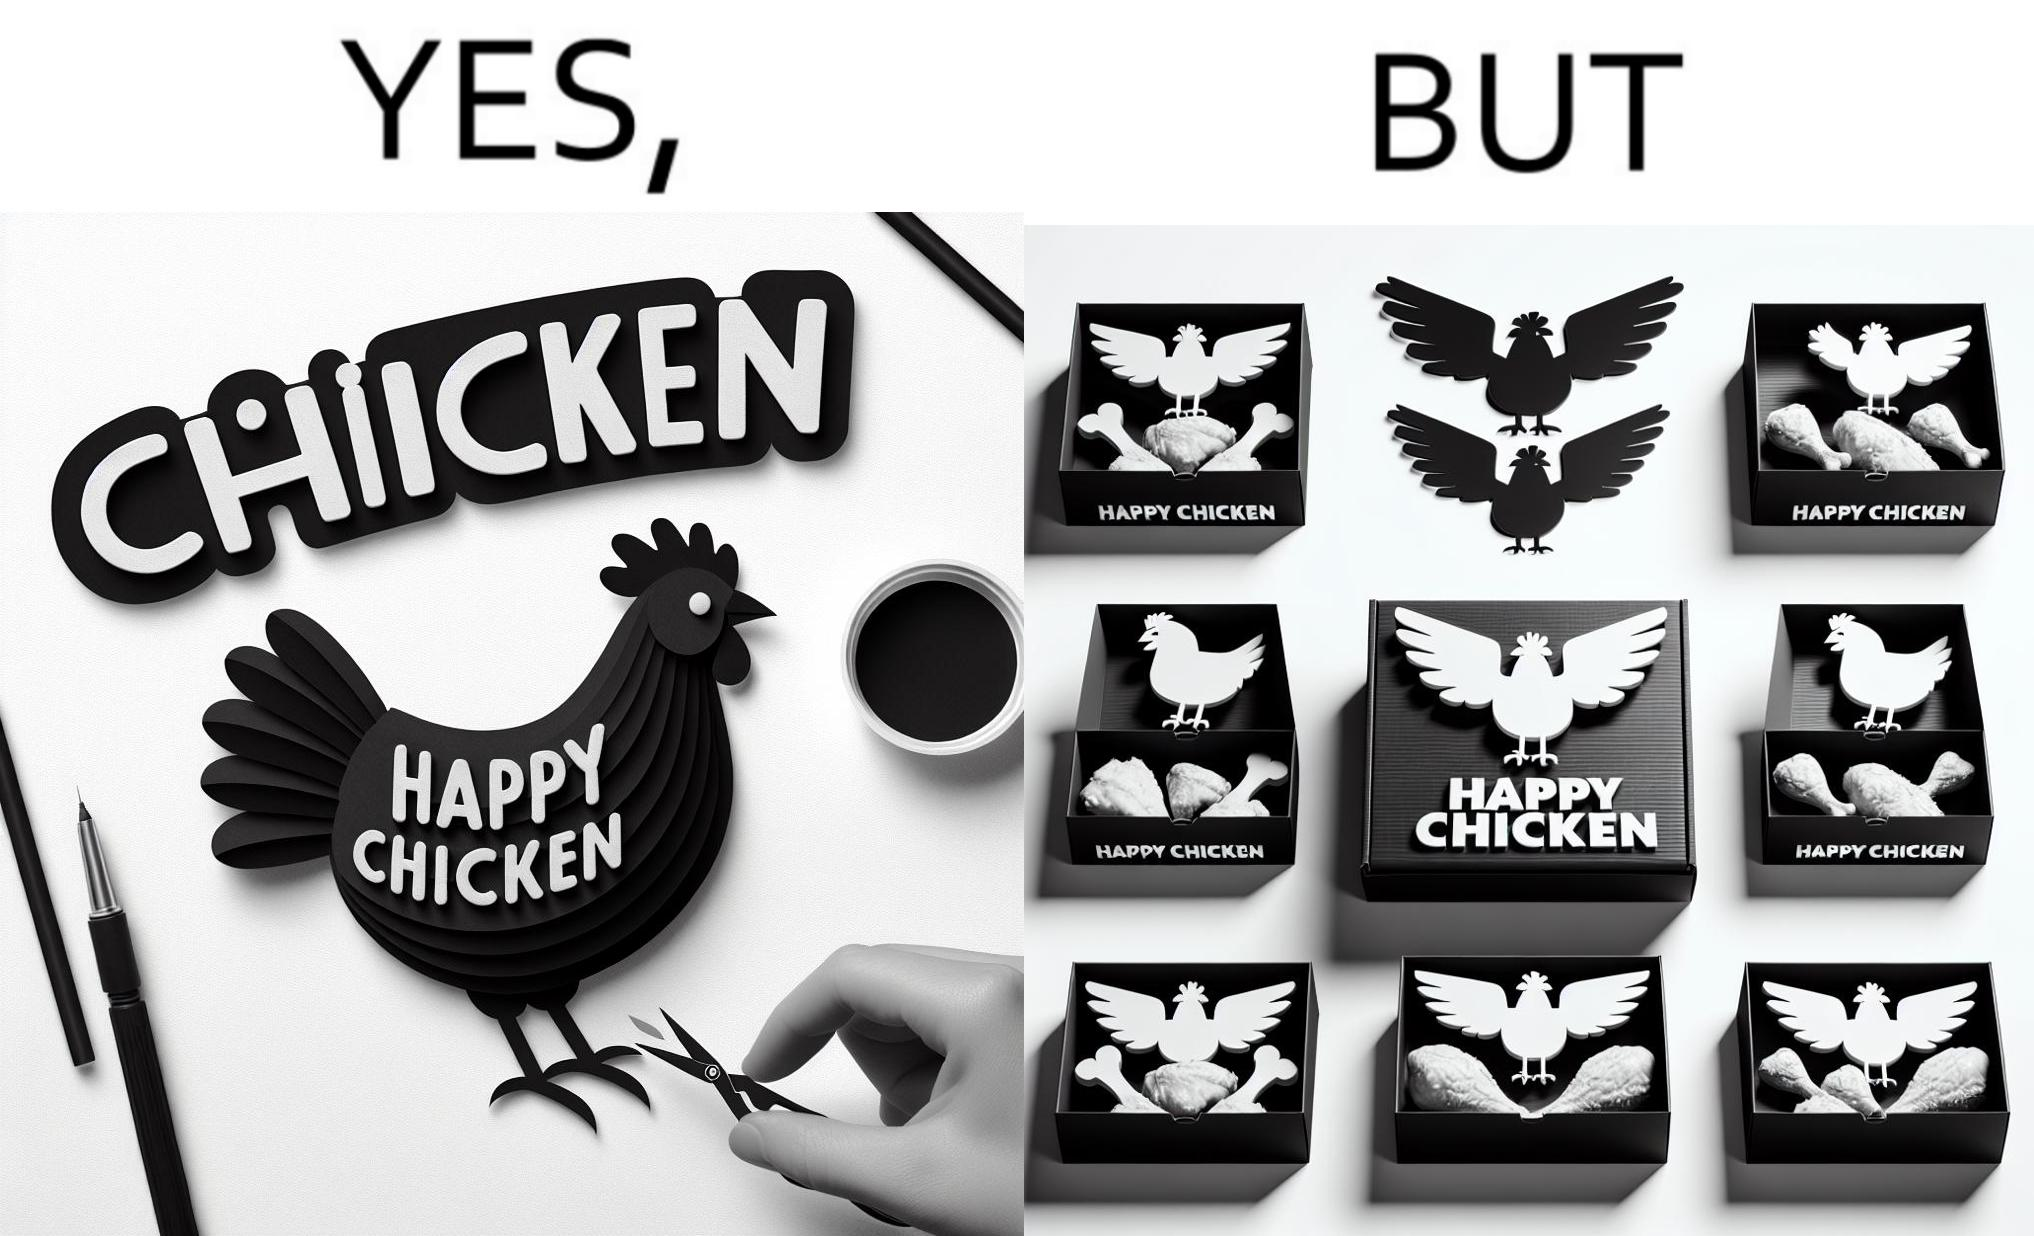Explain the humor or irony in this image. The image is ironic, because in the left image as in the logo it shows happy chicken but in the right image the chicken pieces are shown packed in boxes 